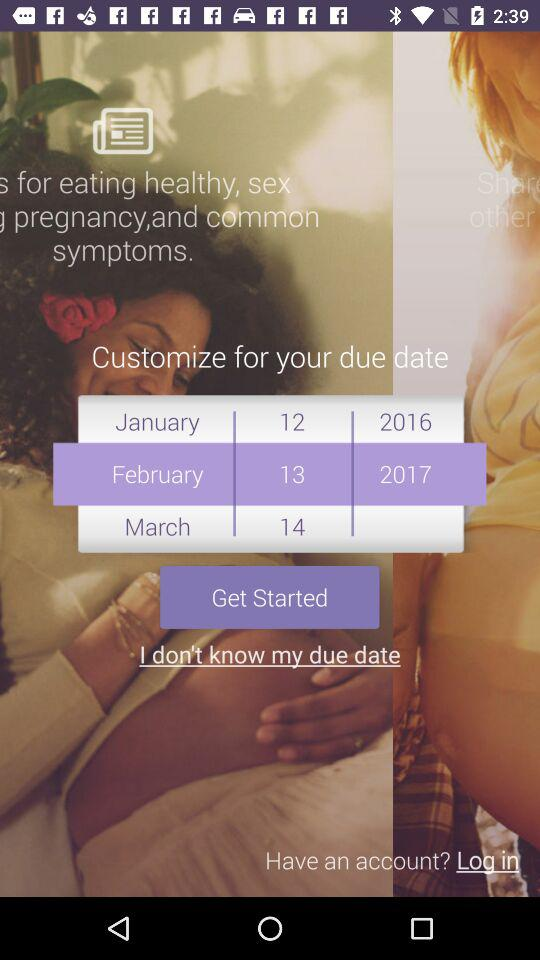How many months are available to choose from?
Answer the question using a single word or phrase. 12 